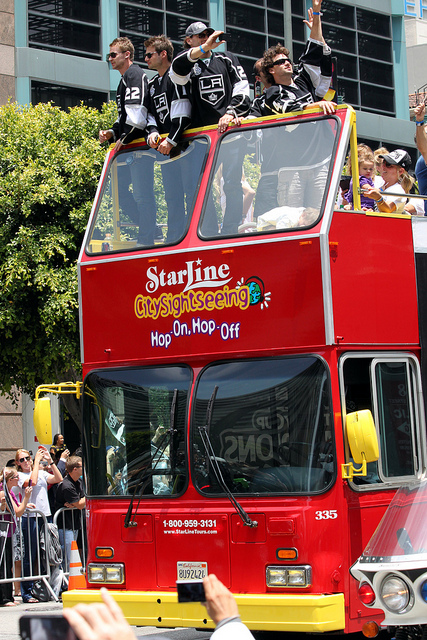Please identify all text content in this image. Star Line citysightseeing Hop off LA 2 LA 22 335 1-800-959-3131 Hop On. 